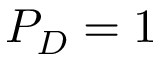<formula> <loc_0><loc_0><loc_500><loc_500>P _ { D } = 1</formula> 